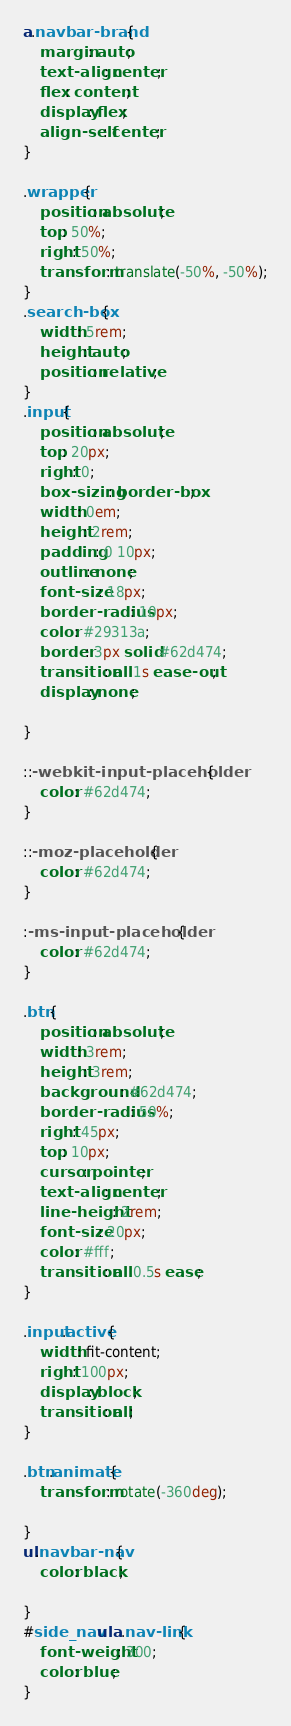<code> <loc_0><loc_0><loc_500><loc_500><_CSS_>a.navbar-brand{
    margin: auto;
    text-align: center;
    flex: content;
    display: flex;
    align-self: center;
}

.wrapper{
    position: absolute;
    top: 50%;
    right: 50%;
    transform: translate(-50%, -50%);
}
.search-box{
    width: 5rem;
    height: auto;
    position: relative;
}
.input{
    position: absolute;
    top: 20px;
    right: 0;
    box-sizing: border-box;
    width: 0em;
    height: 2rem;
    padding: 0 10px;
    outline: none;
    font-size: 18px;
    border-radius: 10px;
    color: #29313a;
    border: 3px solid #62d474;
    transition: all 1s ease-out;
    display: none;

}

::-webkit-input-placeholder{
    color: #62d474;
}

::-moz-placeholder{
    color: #62d474;
}

:-ms-input-placeholder{
    color: #62d474;
}

.btn{
    position: absolute;
    width: 3rem;
    height: 3rem;
    background: #62d474;
    border-radius: 50%;
    right: 45px;
    top: 10px;
    cursor: pointer;
    text-align: center;
    line-height: 2rem;
    font-size: 20px;
    color: #fff;
    transition: all 0.5s ease;
}

.input.active{
    width: fit-content;
    right: 100px;
    display: block;
    transition: all;
}

.btn.animate{
    transform: rotate(-360deg);
    
}
ul.navbar-nav{
    color: black;

}
#side_nav ul a.nav-link{
    font-weight: 300;
    color: blue;
}
</code> 